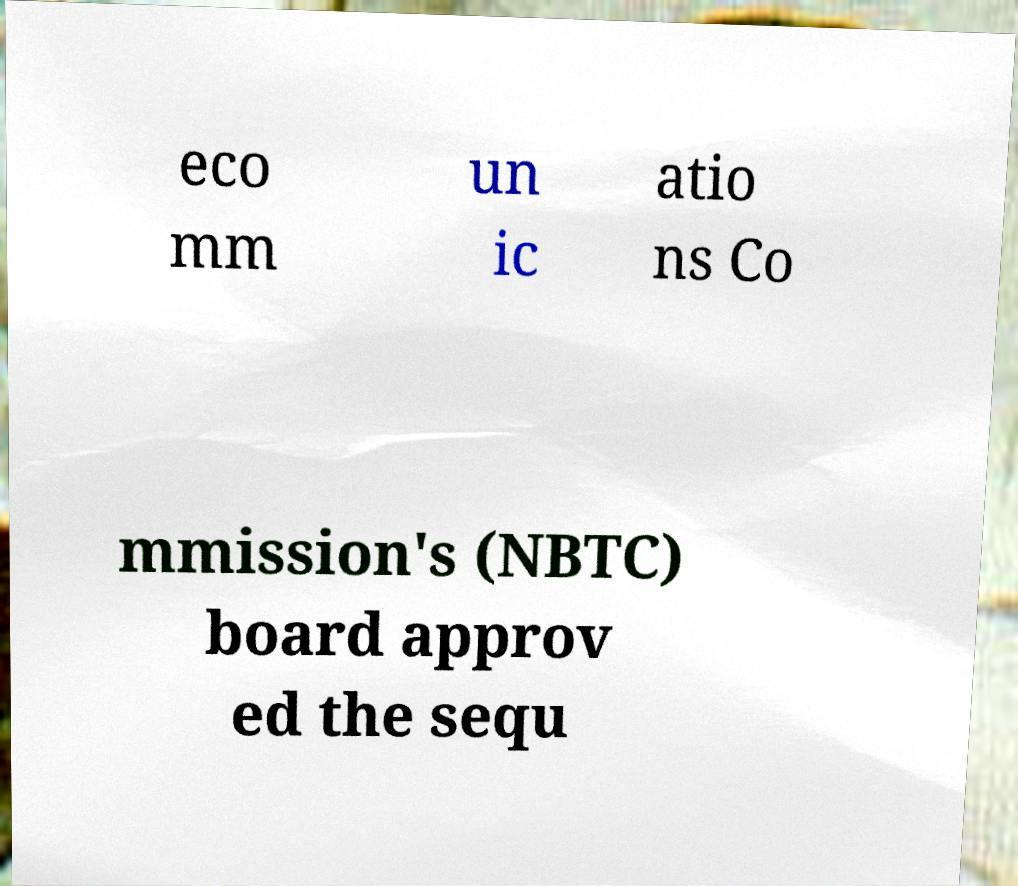I need the written content from this picture converted into text. Can you do that? eco mm un ic atio ns Co mmission's (NBTC) board approv ed the sequ 